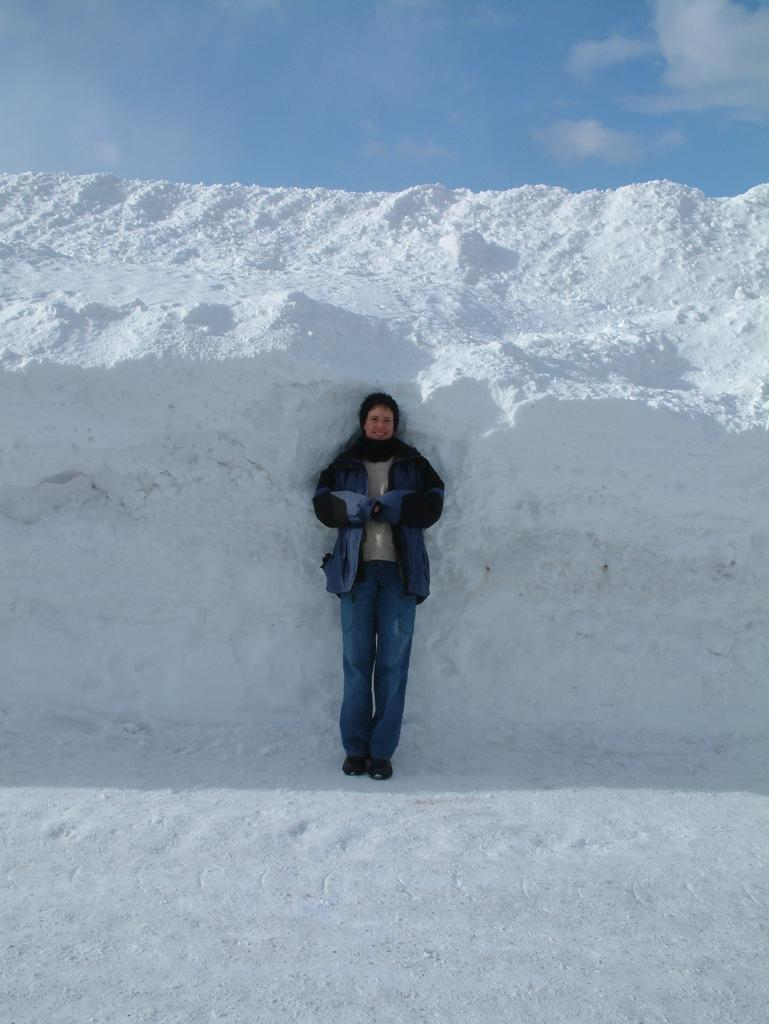What is the main subject of the image? There is a person standing in the center of the image. What can be seen in the background of the image? There is a snow wall in the background of the image. What else is visible in the background of the image? The sky is visible in the background of the image. How many birds are perched on the person's shoulder in the image? There are no birds present in the image. What type of detail can be seen on the person's clothing in the image? The provided facts do not mention any specific details on the person's clothing. 